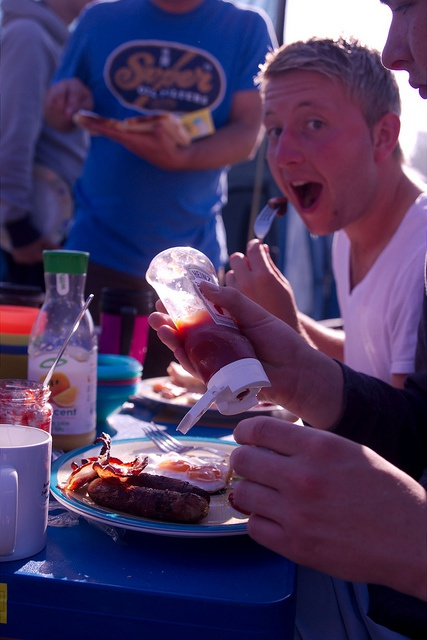Describe the objects in this image and their specific colors. I can see people in gray, black, purple, and lavender tones, people in gray, navy, purple, black, and darkblue tones, people in gray, purple, and violet tones, people in gray, navy, black, darkblue, and purple tones, and bottle in gray, lavender, violet, and purple tones in this image. 